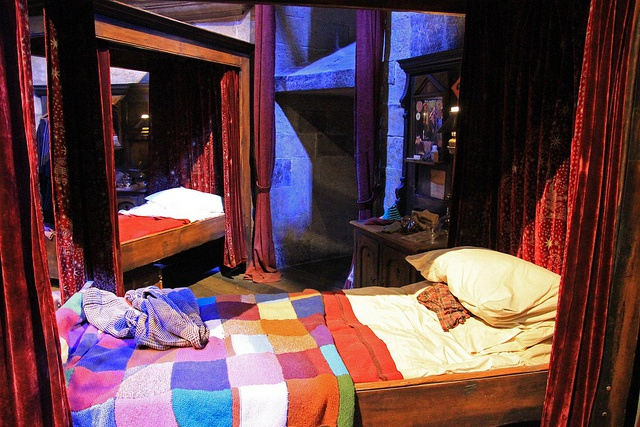Describe the objects in this image and their specific colors. I can see bed in black, white, khaki, red, and maroon tones, bed in black, white, brown, red, and maroon tones, and suitcase in black, maroon, navy, and brown tones in this image. 